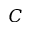<formula> <loc_0><loc_0><loc_500><loc_500>C</formula> 